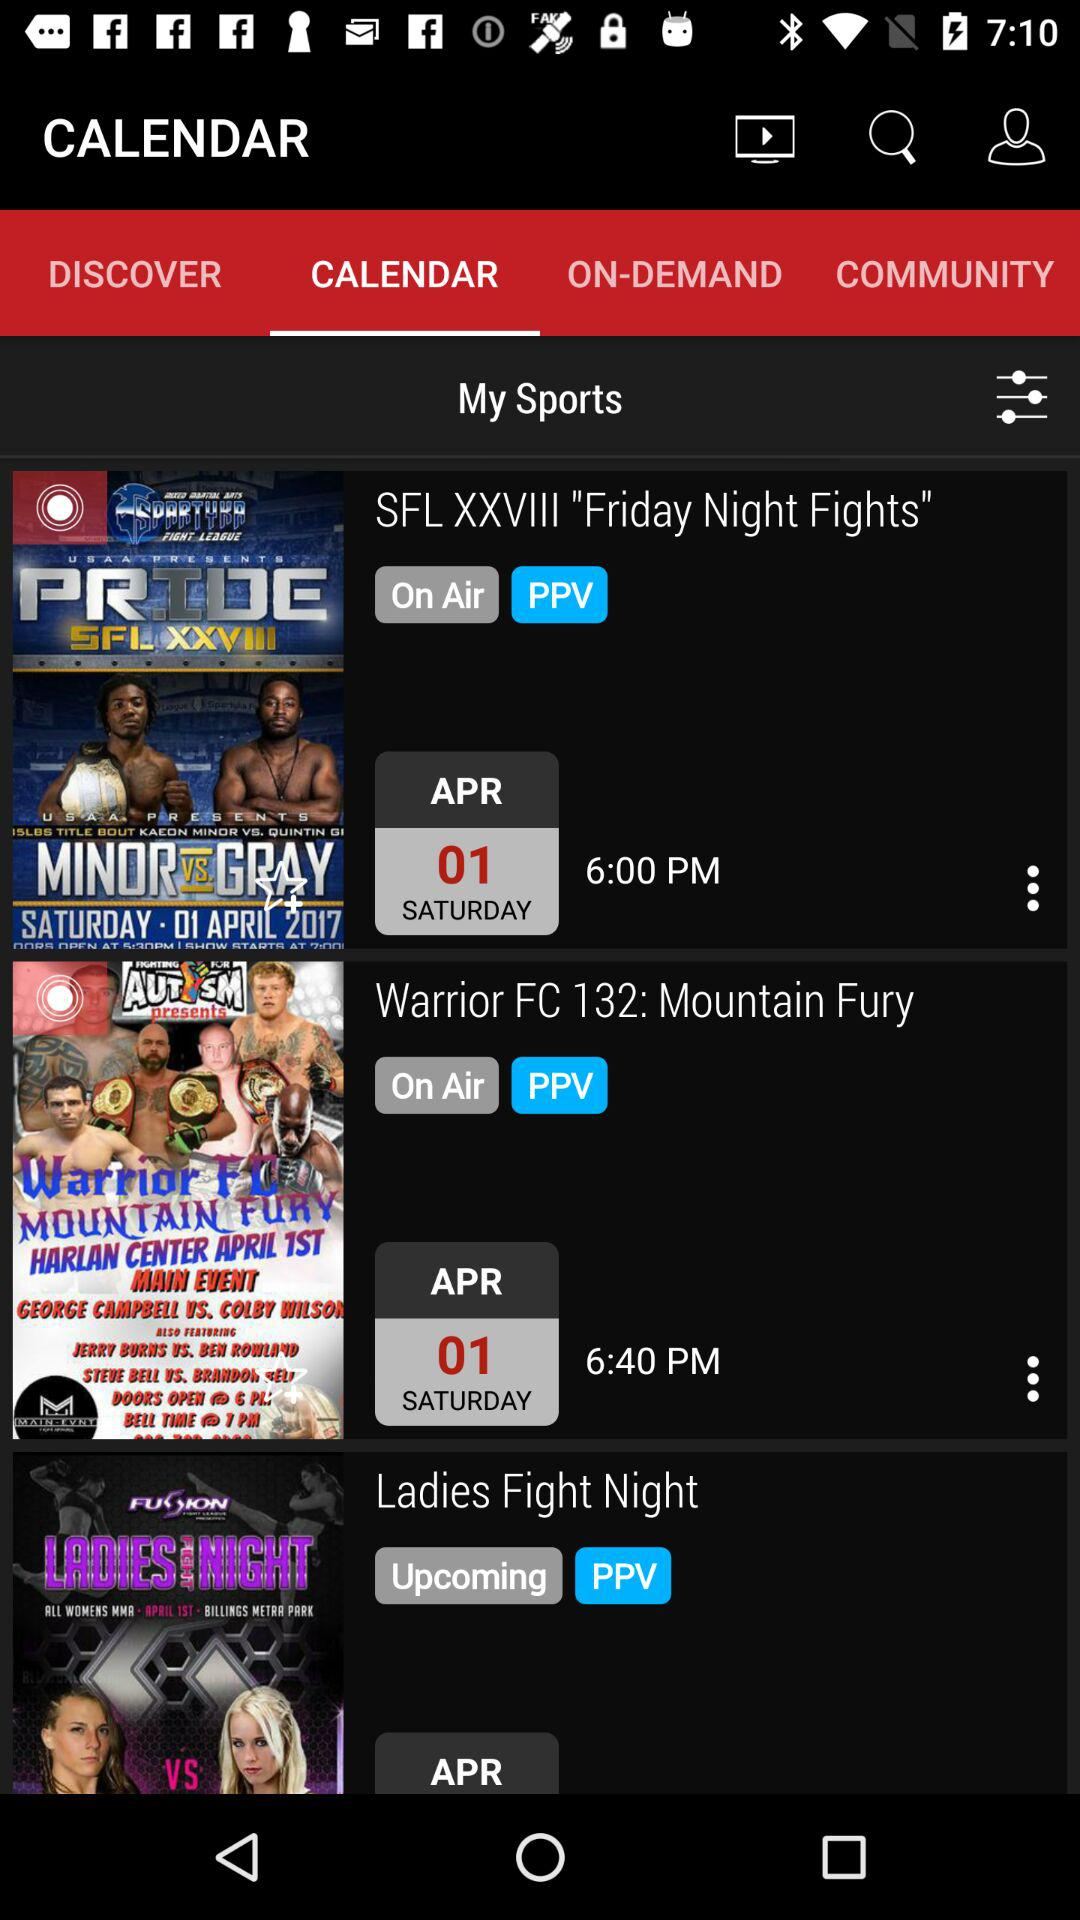What is the time for "Warrior FC 132: Mountain Fury"? The time for "Warrior FC 132: Mountain Fury" is 6:40 p.m. 